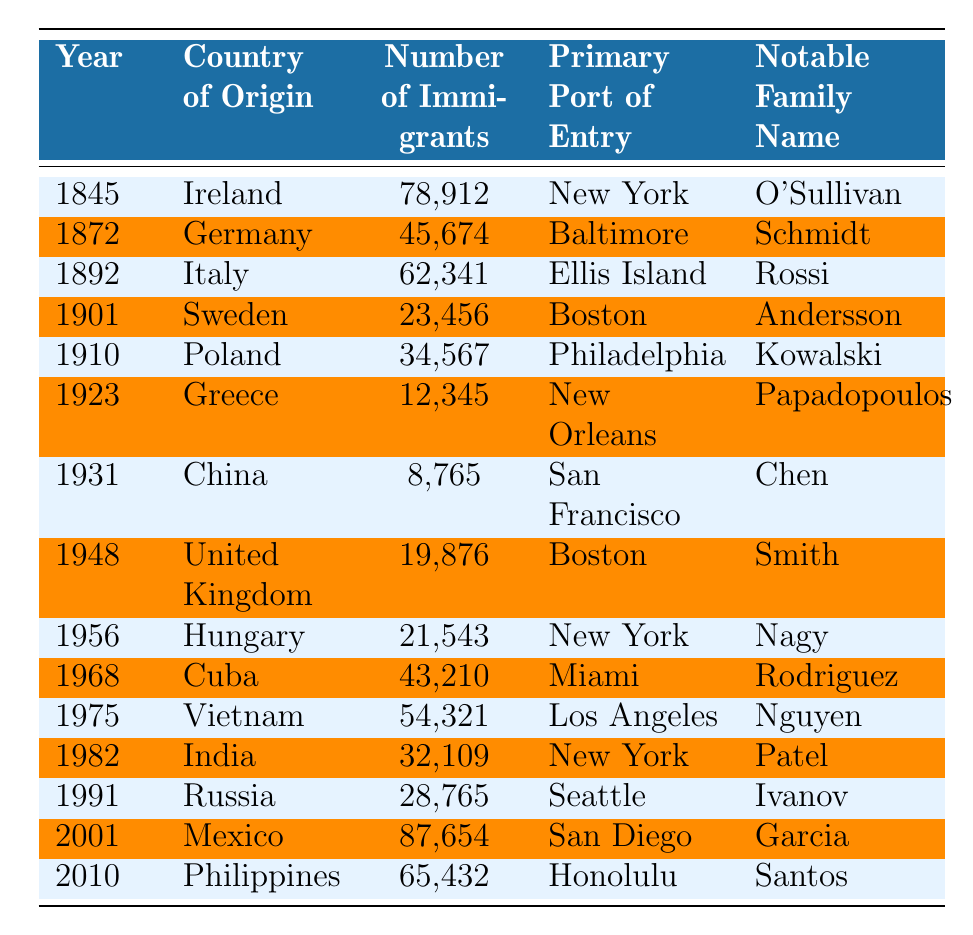What year did the highest number of immigrants arrive from Mexico? According to the table, the year with the highest number of immigrants from Mexico is 2001, where there were 87,654 immigrants.
Answer: 2001 Which country of origin had the least number of immigrants? The country with the least number of immigrants listed in the table is China, with 8,765 immigrants in 1931.
Answer: China What is the total number of immigrants from Ireland and Germany combined? To find the total, we add the number of immigrants from Ireland (78,912) and Germany (45,674): 78,912 + 45,674 = 124,586.
Answer: 124586 Did more immigrants come from Poland or from Vietnam? From the table, Poland had 34,567 immigrants, while Vietnam had 54,321 immigrants. Since 54,321 is greater than 34,567, more immigrants came from Vietnam.
Answer: Yes In which year did the notable family name "Patel" appear in the table? The notable family name "Patel" appears in the year 1982, associated with Indian immigrants.
Answer: 1982 What is the average number of immigrants over all the years reflected in the table? To find the average, we sum all the immigrants: 78912 + 45674 + 62341 + 23456 + 34567 + 12345 + 8765 + 19876 + 21543 + 43210 + 54321 + 32109 + 28765 + 87654 + 65432 = 487,375. There are 15 years, so the average is 487375 / 15 = 32491.67.
Answer: 32491.67 Is the primary port of entry for immigrants from Italy Ellis Island? The table indicates that the primary port of entry for immigrants from Italy in 1892 was indeed Ellis Island.
Answer: Yes In how many years did the number of immigrants exceed 50,000? Looking over the data, immigrants exceeded 50,000 in the years 1845 (78,912), 1892 (62,341), 1968 (43,210 - less than 50,000), 1975 (54,321), and 2001 (87,654). Therefore, the years exceeding 50,000 are 1845, 1892, 1975, and 2001, totaling 4 years.
Answer: 4 Which notable family name has the highest number of immigrants associated with it? The notable family name associated with the highest number of immigrants is Garcia, from Mexico, with 87,654 immigrants in 2001.
Answer: Garcia Did more immigrants arrive from the United Kingdom or from Greece? The United Kingdom had 19,876 immigrants while Greece had 12,345. Since 19,876 is greater than 12,345, more immigrants arrived from the United Kingdom.
Answer: Yes 